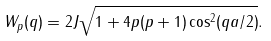<formula> <loc_0><loc_0><loc_500><loc_500>W _ { p } ( q ) = 2 J \sqrt { 1 + 4 p ( p + 1 ) \cos ^ { 2 } ( q a / 2 ) } .</formula> 